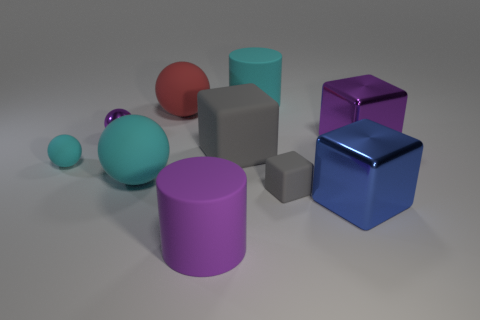What size is the purple thing that is both behind the purple cylinder and in front of the tiny purple metal thing?
Your answer should be very brief. Large. There is a large metal block that is behind the big blue block; is there a purple metallic block that is to the left of it?
Provide a succinct answer. No. There is a tiny gray thing; how many large rubber balls are on the right side of it?
Provide a short and direct response. 0. There is a small rubber object that is the same shape as the big red thing; what color is it?
Your answer should be compact. Cyan. Are the purple object to the left of the red rubber thing and the tiny sphere that is in front of the big purple shiny block made of the same material?
Your answer should be very brief. No. There is a tiny cube; does it have the same color as the big cylinder that is behind the large purple rubber object?
Your answer should be compact. No. There is a purple thing that is to the left of the large cyan matte cylinder and right of the purple metal sphere; what is its shape?
Ensure brevity in your answer.  Cylinder. What number of big shiny blocks are there?
Offer a very short reply. 2. What is the shape of the large metal thing that is the same color as the metal ball?
Offer a very short reply. Cube. There is a purple object that is the same shape as the blue thing; what size is it?
Your answer should be very brief. Large. 